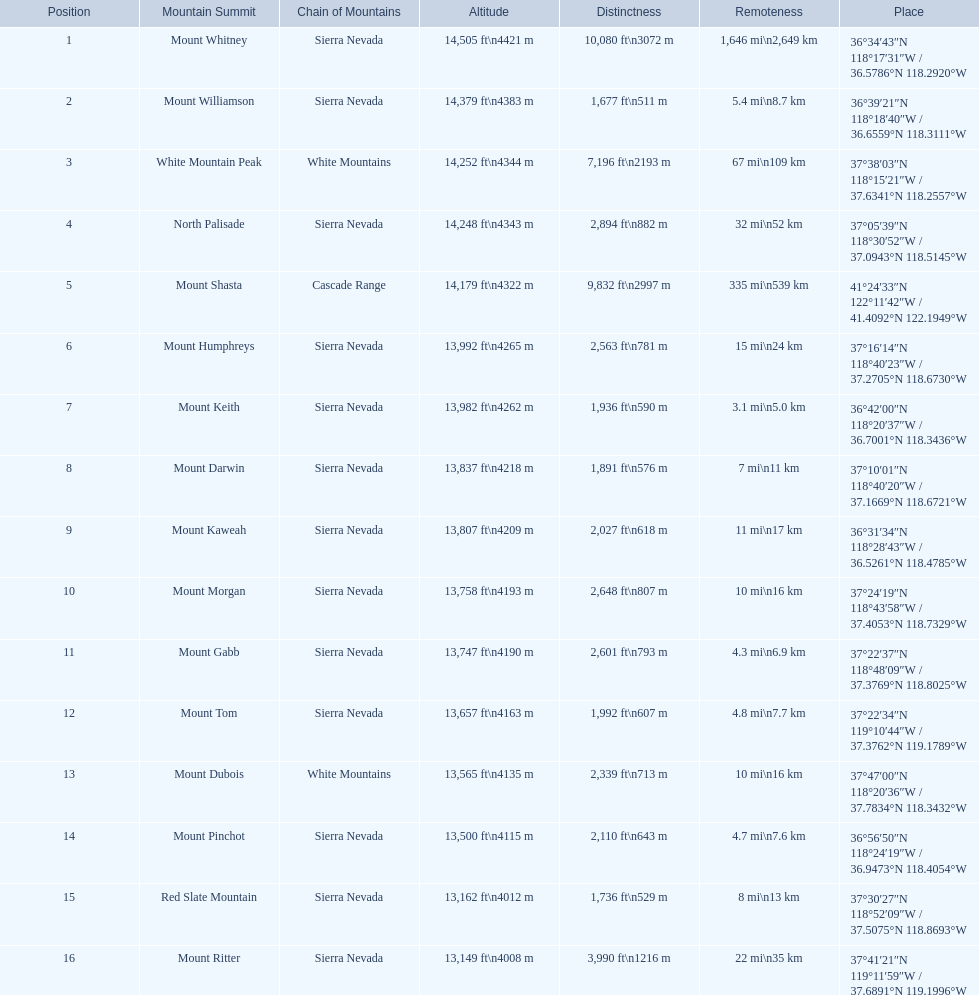What are all of the mountain peaks? Mount Whitney, Mount Williamson, White Mountain Peak, North Palisade, Mount Shasta, Mount Humphreys, Mount Keith, Mount Darwin, Mount Kaweah, Mount Morgan, Mount Gabb, Mount Tom, Mount Dubois, Mount Pinchot, Red Slate Mountain, Mount Ritter. In what ranges are they located? Sierra Nevada, Sierra Nevada, White Mountains, Sierra Nevada, Cascade Range, Sierra Nevada, Sierra Nevada, Sierra Nevada, Sierra Nevada, Sierra Nevada, Sierra Nevada, Sierra Nevada, White Mountains, Sierra Nevada, Sierra Nevada, Sierra Nevada. And which mountain peak is in the cascade range? Mount Shasta. 